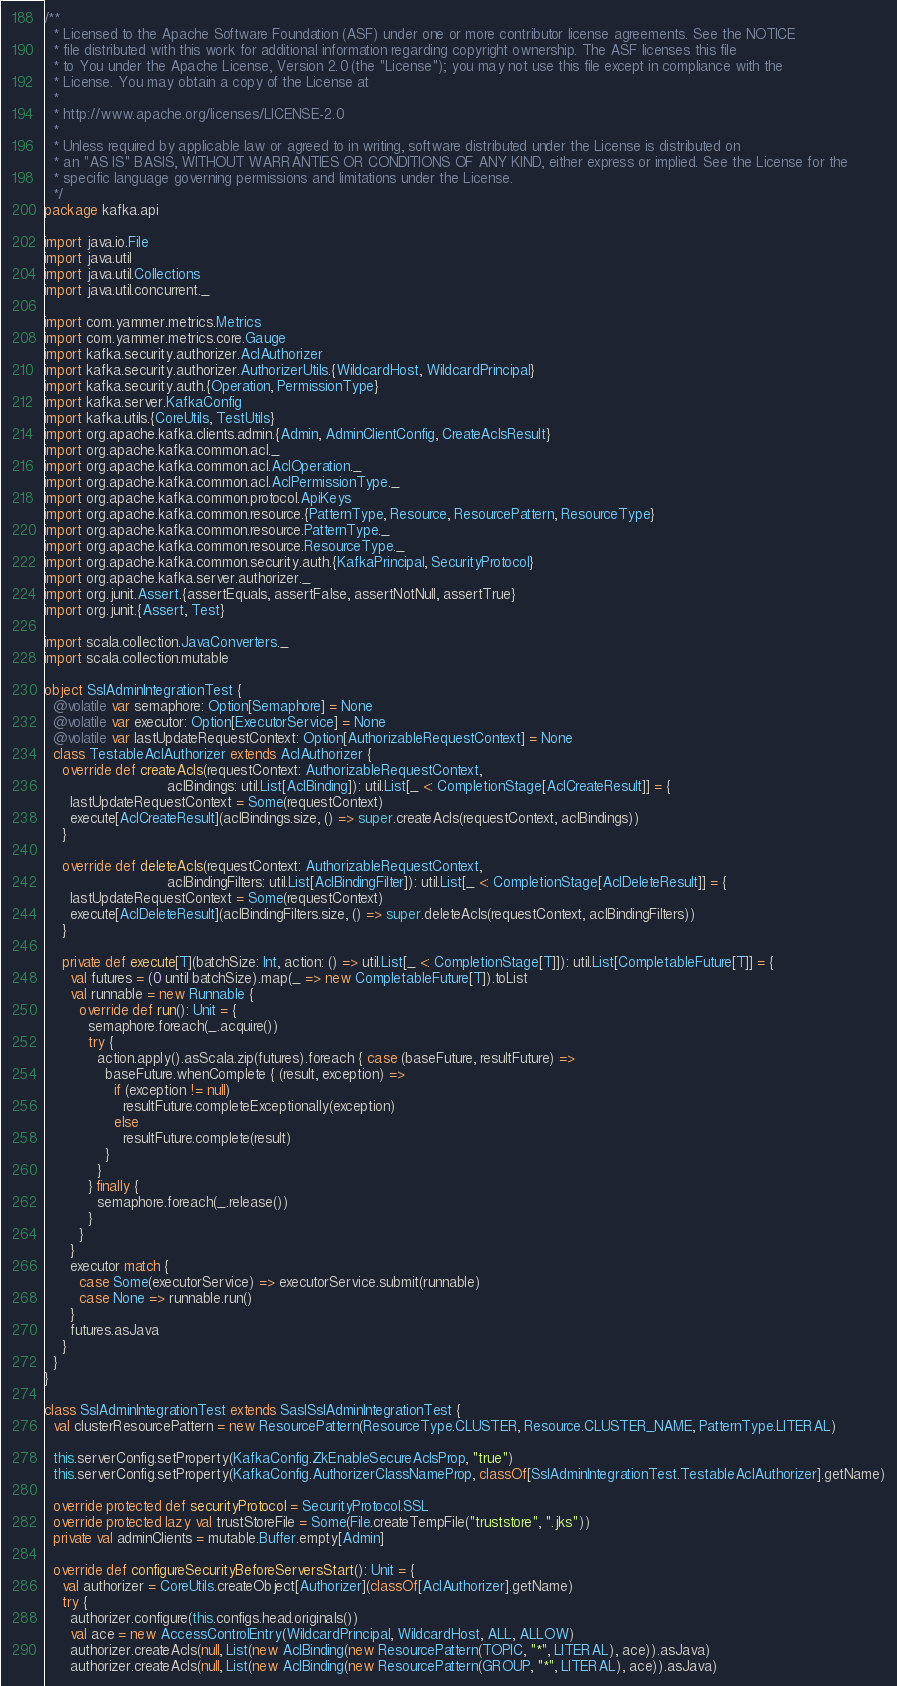Convert code to text. <code><loc_0><loc_0><loc_500><loc_500><_Scala_>/**
  * Licensed to the Apache Software Foundation (ASF) under one or more contributor license agreements. See the NOTICE
  * file distributed with this work for additional information regarding copyright ownership. The ASF licenses this file
  * to You under the Apache License, Version 2.0 (the "License"); you may not use this file except in compliance with the
  * License. You may obtain a copy of the License at
  *
  * http://www.apache.org/licenses/LICENSE-2.0
  *
  * Unless required by applicable law or agreed to in writing, software distributed under the License is distributed on
  * an "AS IS" BASIS, WITHOUT WARRANTIES OR CONDITIONS OF ANY KIND, either express or implied. See the License for the
  * specific language governing permissions and limitations under the License.
  */
package kafka.api

import java.io.File
import java.util
import java.util.Collections
import java.util.concurrent._

import com.yammer.metrics.Metrics
import com.yammer.metrics.core.Gauge
import kafka.security.authorizer.AclAuthorizer
import kafka.security.authorizer.AuthorizerUtils.{WildcardHost, WildcardPrincipal}
import kafka.security.auth.{Operation, PermissionType}
import kafka.server.KafkaConfig
import kafka.utils.{CoreUtils, TestUtils}
import org.apache.kafka.clients.admin.{Admin, AdminClientConfig, CreateAclsResult}
import org.apache.kafka.common.acl._
import org.apache.kafka.common.acl.AclOperation._
import org.apache.kafka.common.acl.AclPermissionType._
import org.apache.kafka.common.protocol.ApiKeys
import org.apache.kafka.common.resource.{PatternType, Resource, ResourcePattern, ResourceType}
import org.apache.kafka.common.resource.PatternType._
import org.apache.kafka.common.resource.ResourceType._
import org.apache.kafka.common.security.auth.{KafkaPrincipal, SecurityProtocol}
import org.apache.kafka.server.authorizer._
import org.junit.Assert.{assertEquals, assertFalse, assertNotNull, assertTrue}
import org.junit.{Assert, Test}

import scala.collection.JavaConverters._
import scala.collection.mutable

object SslAdminIntegrationTest {
  @volatile var semaphore: Option[Semaphore] = None
  @volatile var executor: Option[ExecutorService] = None
  @volatile var lastUpdateRequestContext: Option[AuthorizableRequestContext] = None
  class TestableAclAuthorizer extends AclAuthorizer {
    override def createAcls(requestContext: AuthorizableRequestContext,
                            aclBindings: util.List[AclBinding]): util.List[_ <: CompletionStage[AclCreateResult]] = {
      lastUpdateRequestContext = Some(requestContext)
      execute[AclCreateResult](aclBindings.size, () => super.createAcls(requestContext, aclBindings))
    }

    override def deleteAcls(requestContext: AuthorizableRequestContext,
                            aclBindingFilters: util.List[AclBindingFilter]): util.List[_ <: CompletionStage[AclDeleteResult]] = {
      lastUpdateRequestContext = Some(requestContext)
      execute[AclDeleteResult](aclBindingFilters.size, () => super.deleteAcls(requestContext, aclBindingFilters))
    }

    private def execute[T](batchSize: Int, action: () => util.List[_ <: CompletionStage[T]]): util.List[CompletableFuture[T]] = {
      val futures = (0 until batchSize).map(_ => new CompletableFuture[T]).toList
      val runnable = new Runnable {
        override def run(): Unit = {
          semaphore.foreach(_.acquire())
          try {
            action.apply().asScala.zip(futures).foreach { case (baseFuture, resultFuture) =>
              baseFuture.whenComplete { (result, exception) =>
                if (exception != null)
                  resultFuture.completeExceptionally(exception)
                else
                  resultFuture.complete(result)
              }
            }
          } finally {
            semaphore.foreach(_.release())
          }
        }
      }
      executor match {
        case Some(executorService) => executorService.submit(runnable)
        case None => runnable.run()
      }
      futures.asJava
    }
  }
}

class SslAdminIntegrationTest extends SaslSslAdminIntegrationTest {
  val clusterResourcePattern = new ResourcePattern(ResourceType.CLUSTER, Resource.CLUSTER_NAME, PatternType.LITERAL)

  this.serverConfig.setProperty(KafkaConfig.ZkEnableSecureAclsProp, "true")
  this.serverConfig.setProperty(KafkaConfig.AuthorizerClassNameProp, classOf[SslAdminIntegrationTest.TestableAclAuthorizer].getName)

  override protected def securityProtocol = SecurityProtocol.SSL
  override protected lazy val trustStoreFile = Some(File.createTempFile("truststore", ".jks"))
  private val adminClients = mutable.Buffer.empty[Admin]

  override def configureSecurityBeforeServersStart(): Unit = {
    val authorizer = CoreUtils.createObject[Authorizer](classOf[AclAuthorizer].getName)
    try {
      authorizer.configure(this.configs.head.originals())
      val ace = new AccessControlEntry(WildcardPrincipal, WildcardHost, ALL, ALLOW)
      authorizer.createAcls(null, List(new AclBinding(new ResourcePattern(TOPIC, "*", LITERAL), ace)).asJava)
      authorizer.createAcls(null, List(new AclBinding(new ResourcePattern(GROUP, "*", LITERAL), ace)).asJava)
</code> 